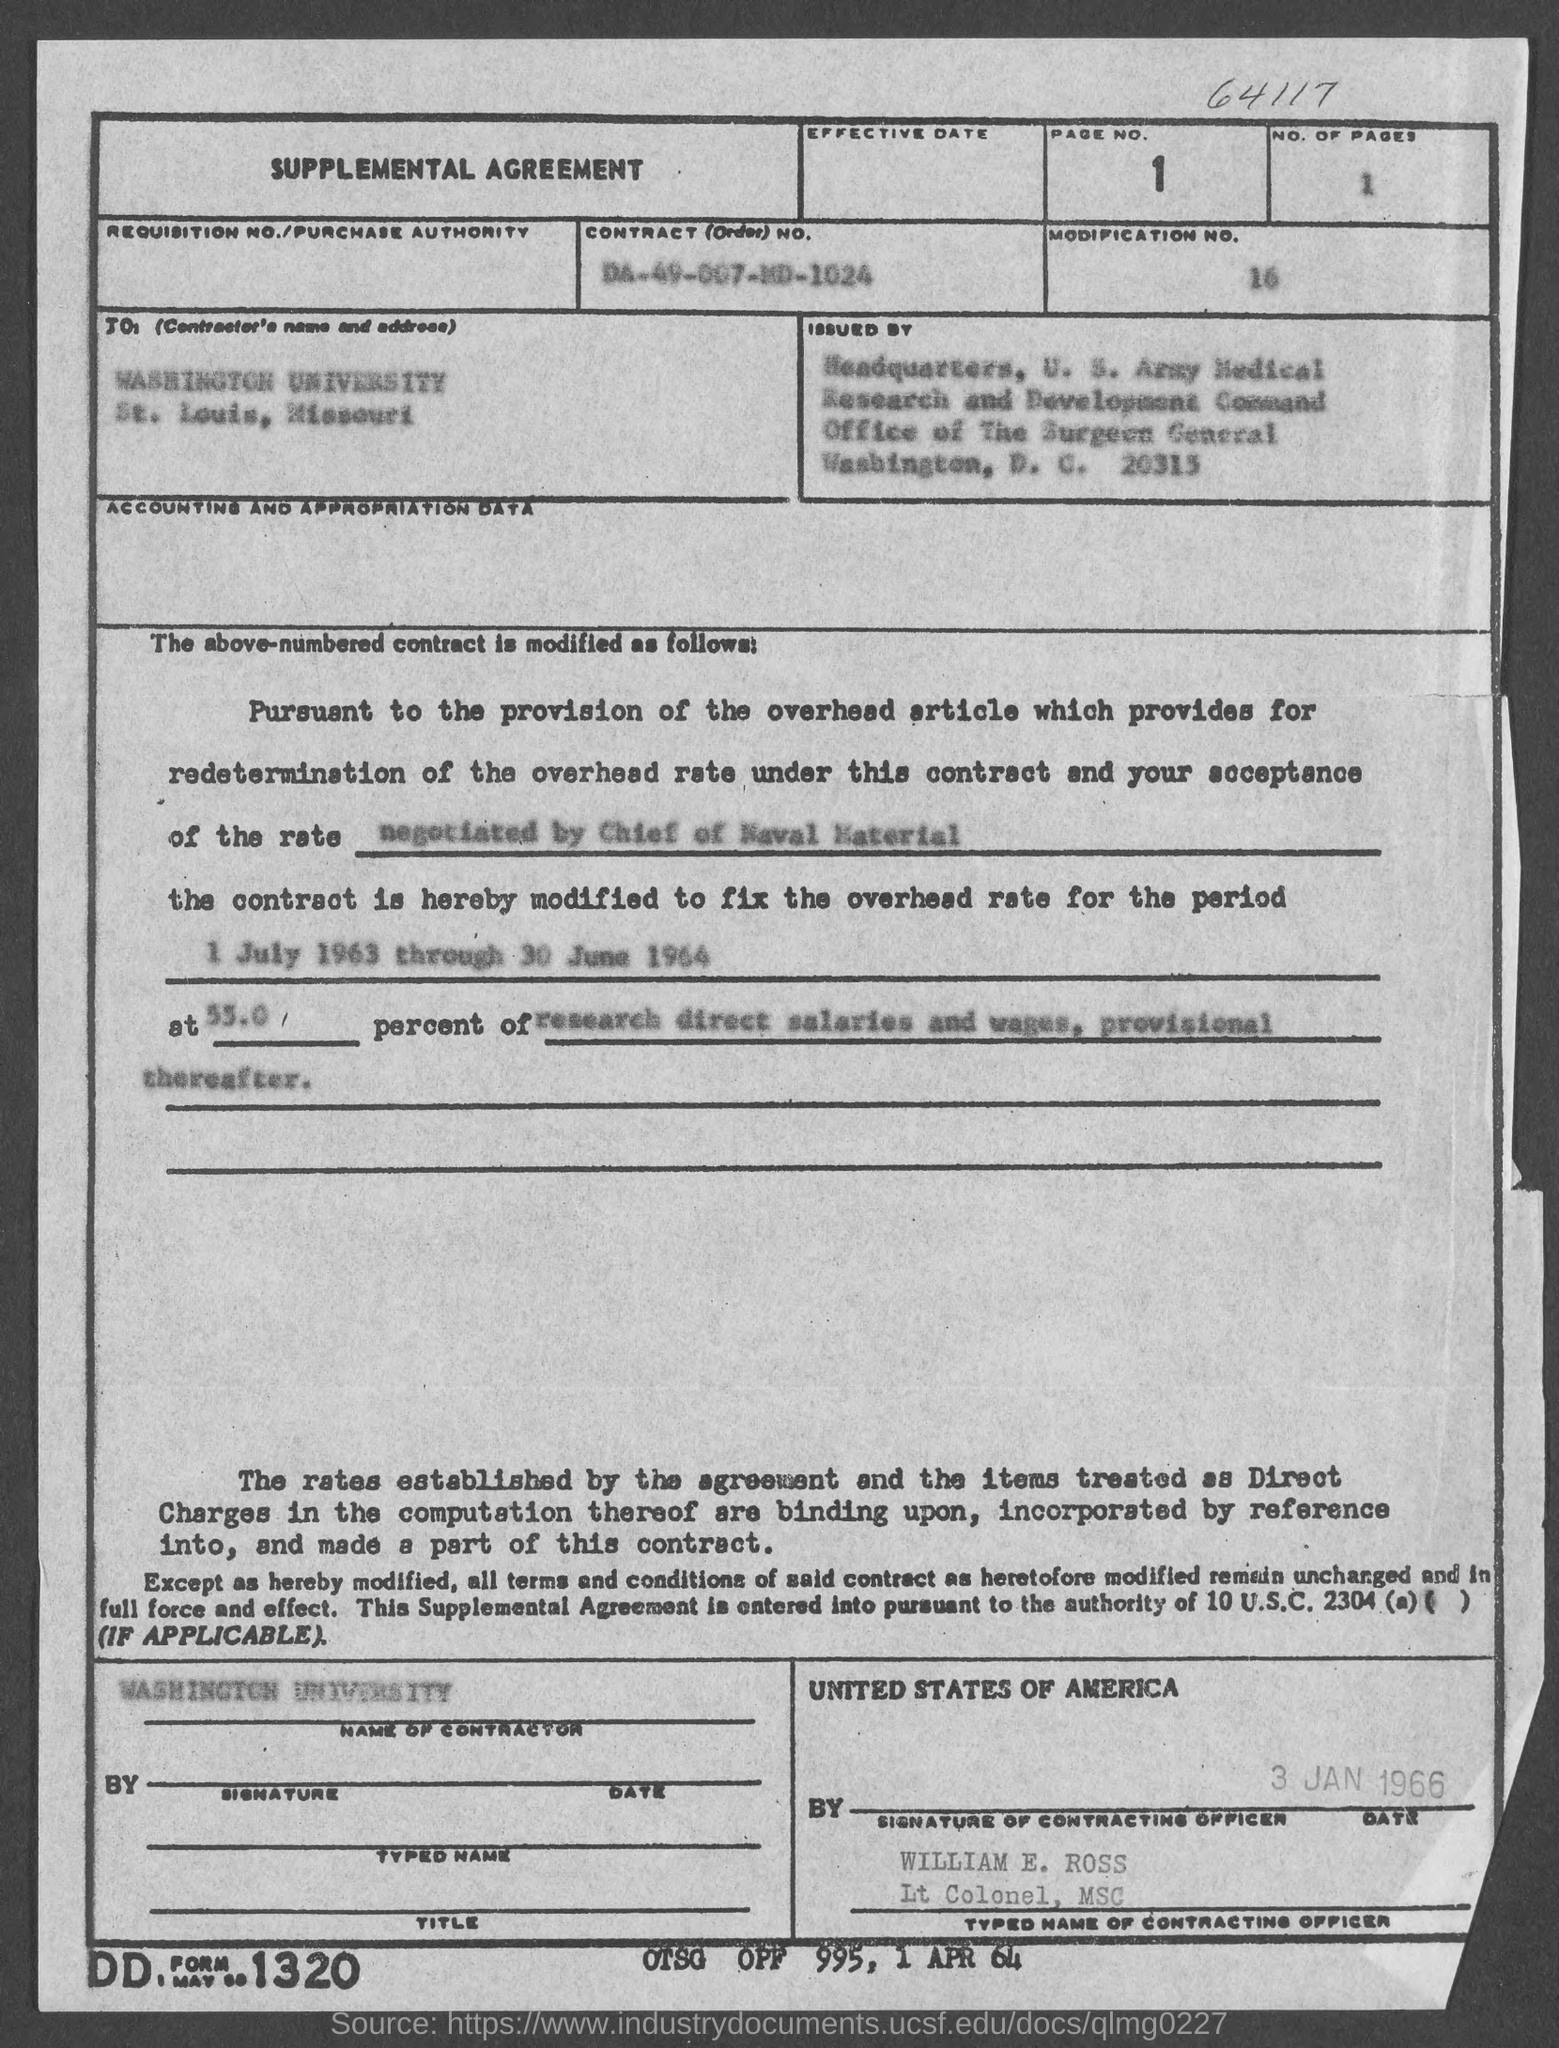What is the page no.?
Give a very brief answer. 1. What is the no. of pages?
Keep it short and to the point. 1. What is the modification no.?
Offer a very short reply. 16. What is the contract no.?
Offer a terse response. DA-49-007-MD-1024. In which state is washington university at?
Give a very brief answer. Missouri. What is the name of the contracting officer?
Your response must be concise. William E. Ross. 